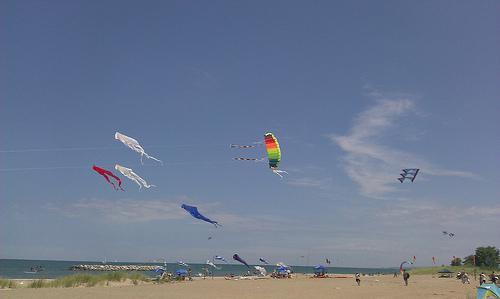Question: where is this picture taken?
Choices:
A. Lake.
B. Beach.
C. Forest.
D. Park.
Answer with the letter. Answer: B Question: what are the people doing at the beach?
Choices:
A. Surfing.
B. Tanning.
C. Flying kites.
D. Throwing a frisbee.
Answer with the letter. Answer: C Question: how many airplanes are pictured?
Choices:
A. One.
B. Two.
C. Zero.
D. Three.
Answer with the letter. Answer: C 